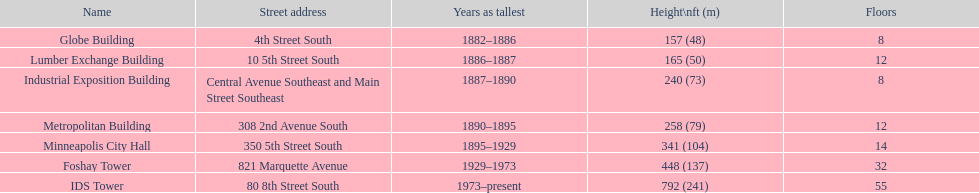What is the number of floors in the globe building? 8. Which structure consists of 14 floors? Minneapolis City Hall. Which building has an equal number of floors as the lumber exchange building? Metropolitan Building. 